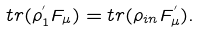<formula> <loc_0><loc_0><loc_500><loc_500>t r ( \rho ^ { ^ { \prime } } _ { 1 } F _ { \mu } ) = t r ( \rho _ { i n } F ^ { ^ { \prime } } _ { \mu } ) .</formula> 